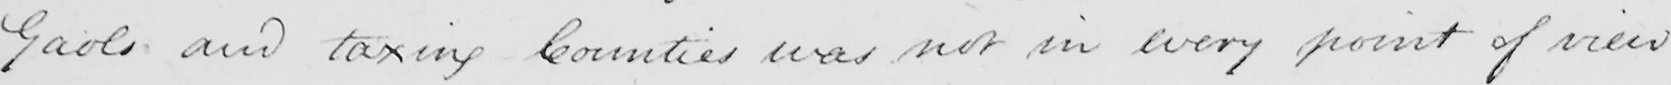Please transcribe the handwritten text in this image. Gaols and taxing Counties was not in every point of view 